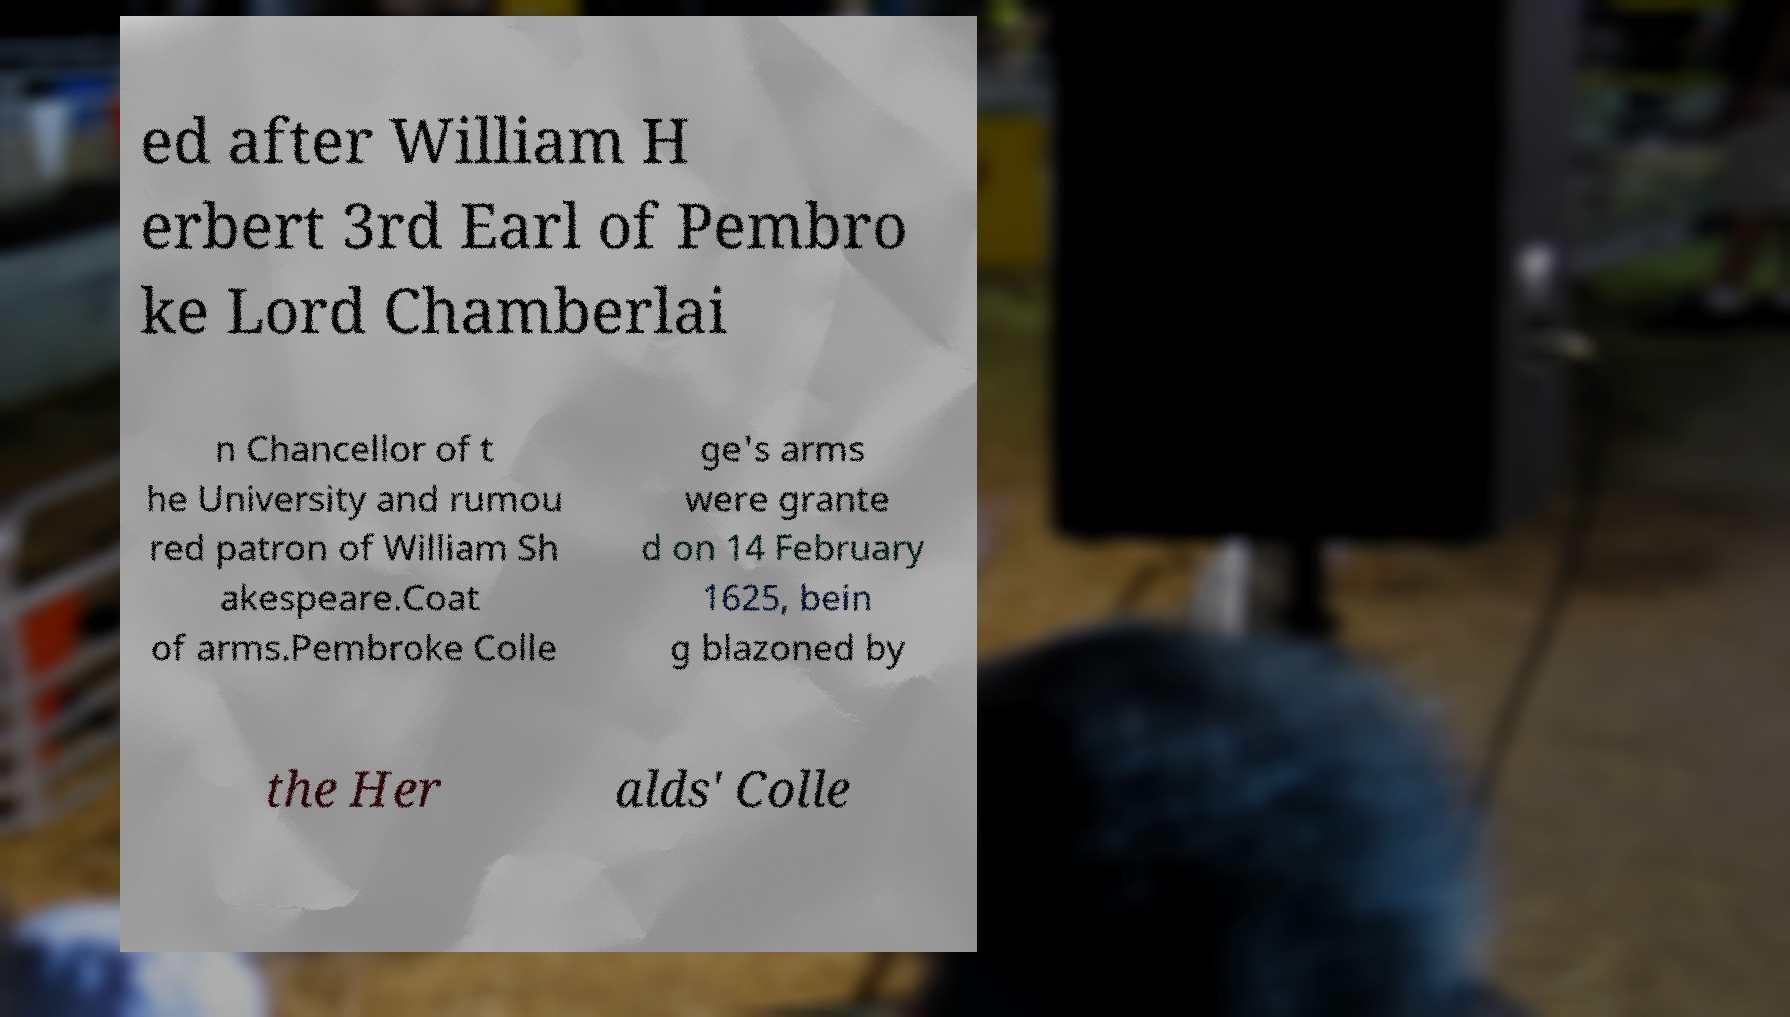What messages or text are displayed in this image? I need them in a readable, typed format. ed after William H erbert 3rd Earl of Pembro ke Lord Chamberlai n Chancellor of t he University and rumou red patron of William Sh akespeare.Coat of arms.Pembroke Colle ge's arms were grante d on 14 February 1625, bein g blazoned by the Her alds' Colle 